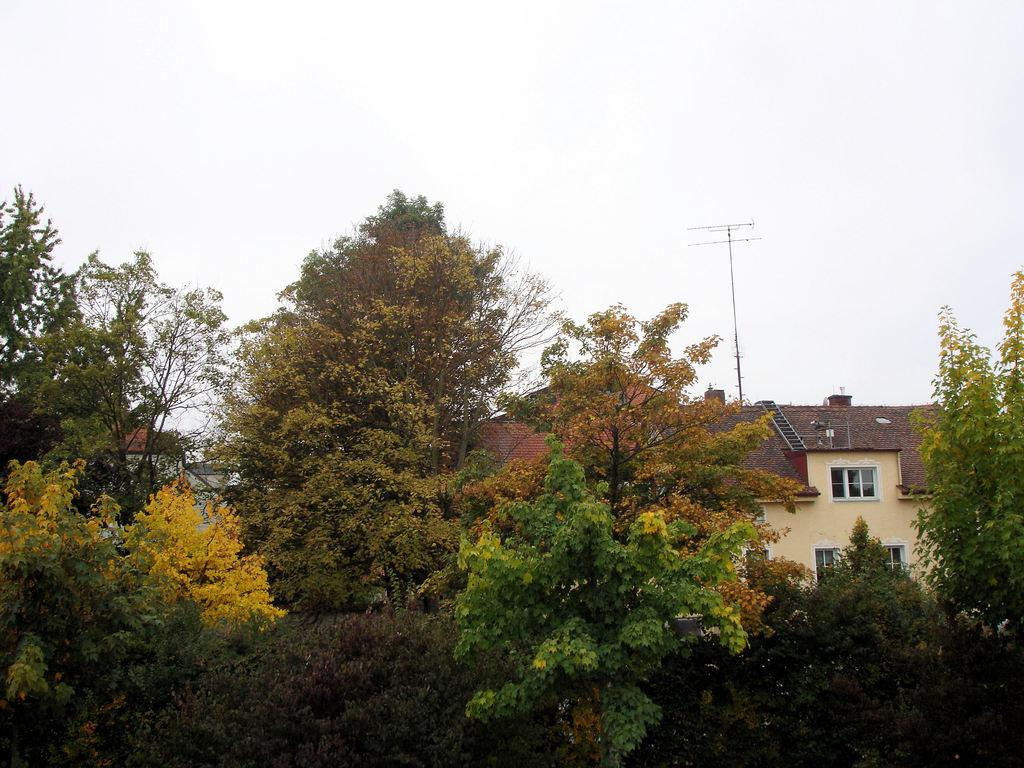What type of structures can be seen in the image? There are houses in the image. What is the surrounding environment like for the houses? The houses are surrounded by green trees and bushes. What is the purpose of the pole in the image? There is an antenna on the pole, which suggests it is used for communication or broadcasting purposes. How would you describe the sky in the image? The sky is bright in the image. What shape is the stone that is being used as an afterthought in the image? There is no stone or afterthought present in the image. 